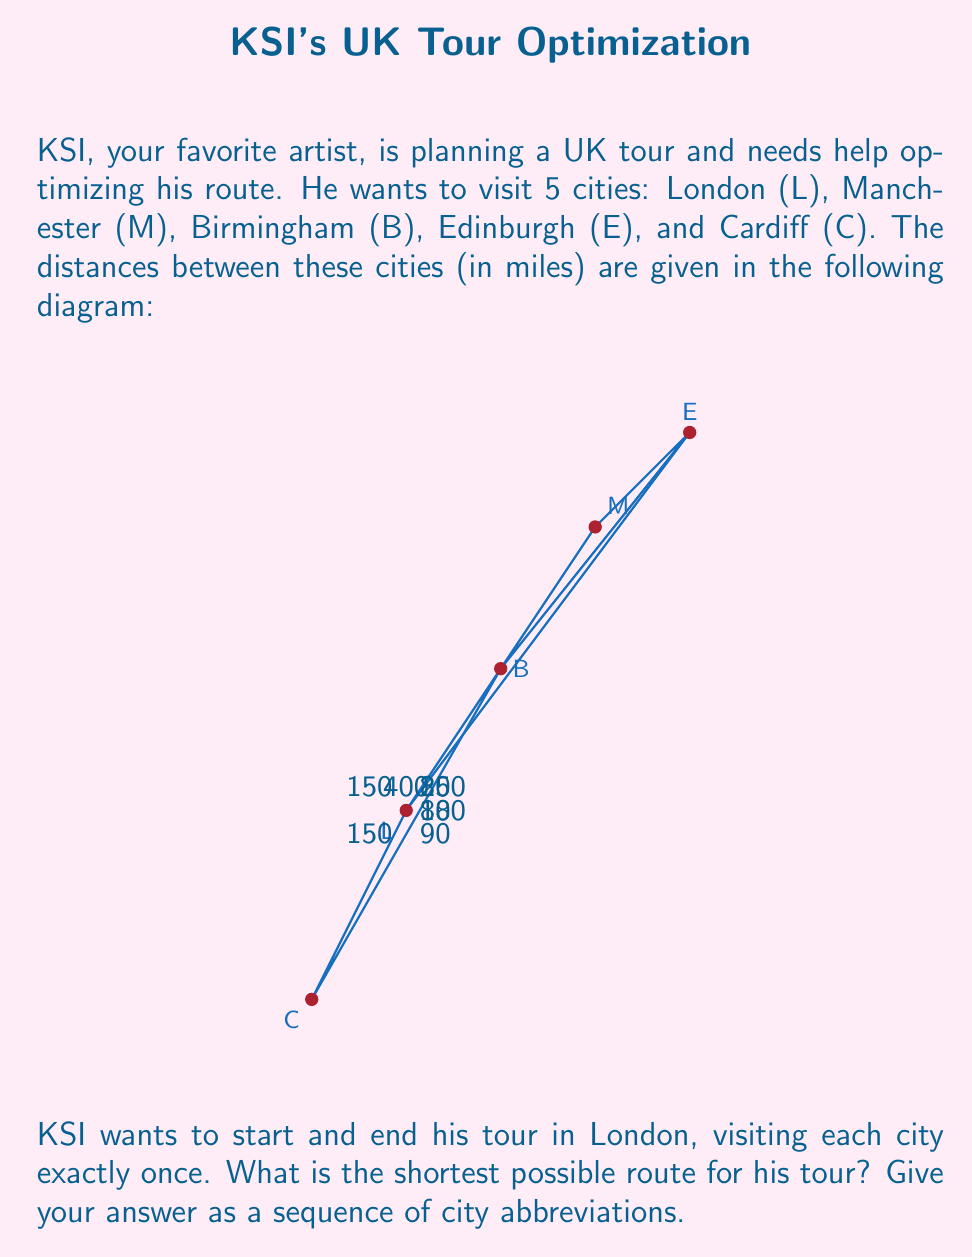Could you help me with this problem? This problem is an instance of the Traveling Salesman Problem (TSP), which aims to find the shortest possible route that visits each city exactly once and returns to the starting point.

For a small number of cities like this, we can solve it using the brute-force method:

1) List all possible routes starting and ending in London:
   L-M-B-E-C-L
   L-M-E-B-C-L
   L-B-M-E-C-L
   L-B-E-M-C-L
   L-C-B-M-E-L
   L-C-B-E-M-L

2) Calculate the total distance for each route:

   L-M-B-E-C-L: 150 + 80 + 200 + 90 + 150 = 670 miles
   L-M-E-B-C-L: 150 + 180 + 200 + 90 + 150 = 770 miles
   L-B-M-E-C-L: 85 + 80 + 180 + 90 + 150 = 585 miles
   L-B-E-M-C-L: 85 + 200 + 180 + 80 + 150 = 695 miles
   L-C-B-M-E-L: 150 + 90 + 80 + 180 + 400 = 900 miles
   L-C-B-E-M-L: 150 + 90 + 200 + 180 + 150 = 770 miles

3) The shortest route is L-B-M-E-C-L with a total distance of 585 miles.

This solution method, while straightforward, becomes impractical for larger numbers of cities due to the factorial growth in the number of possible routes. For larger problems, more advanced algorithms like the Held-Karp algorithm or heuristic methods are typically used.
Answer: L-B-M-E-C-L 